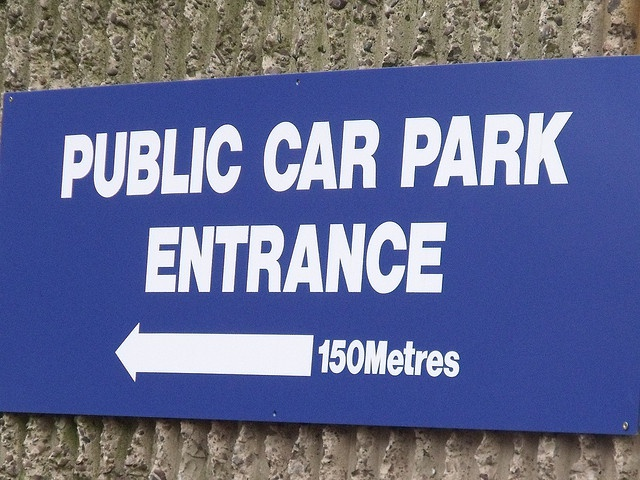Describe the objects in this image and their specific colors. I can see various objects in this image with different colors. 